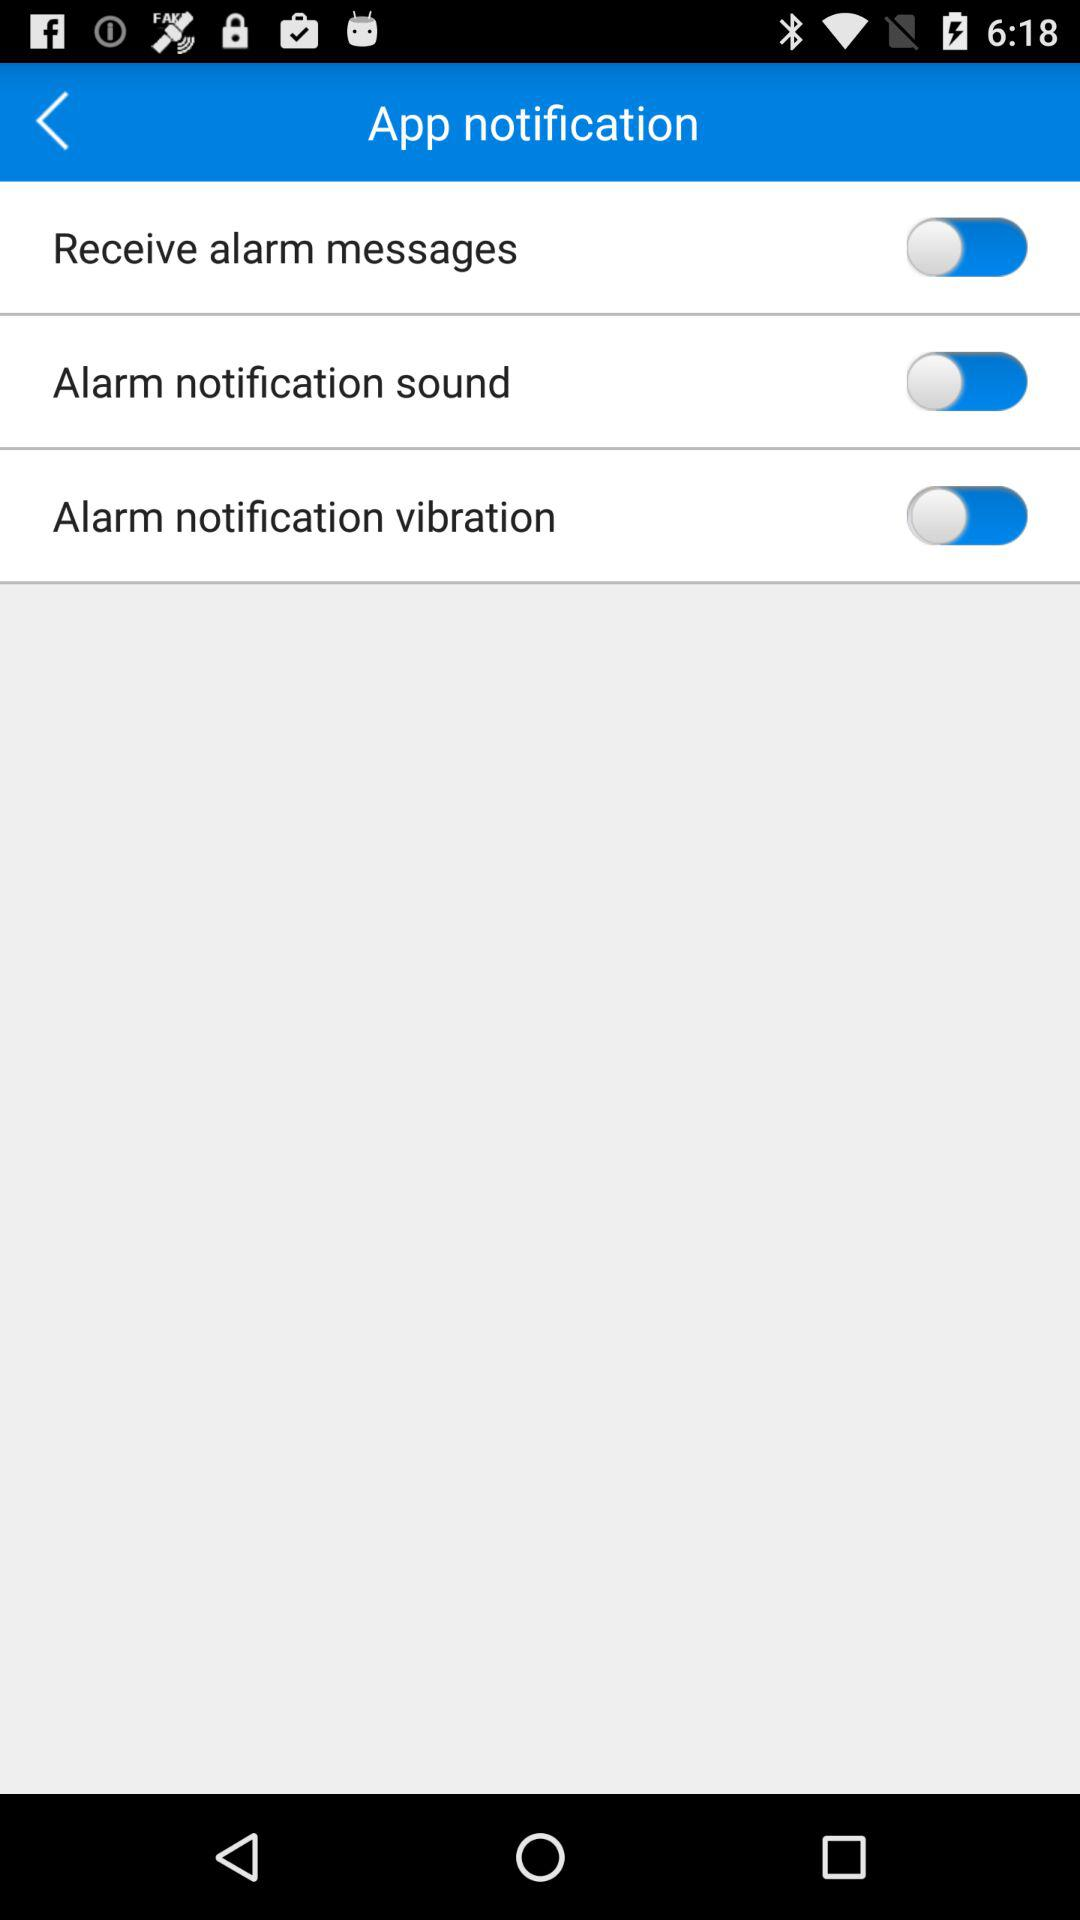What is the status of "Alarm notification sound"? The status of "Alarm notification sound" is "off". 